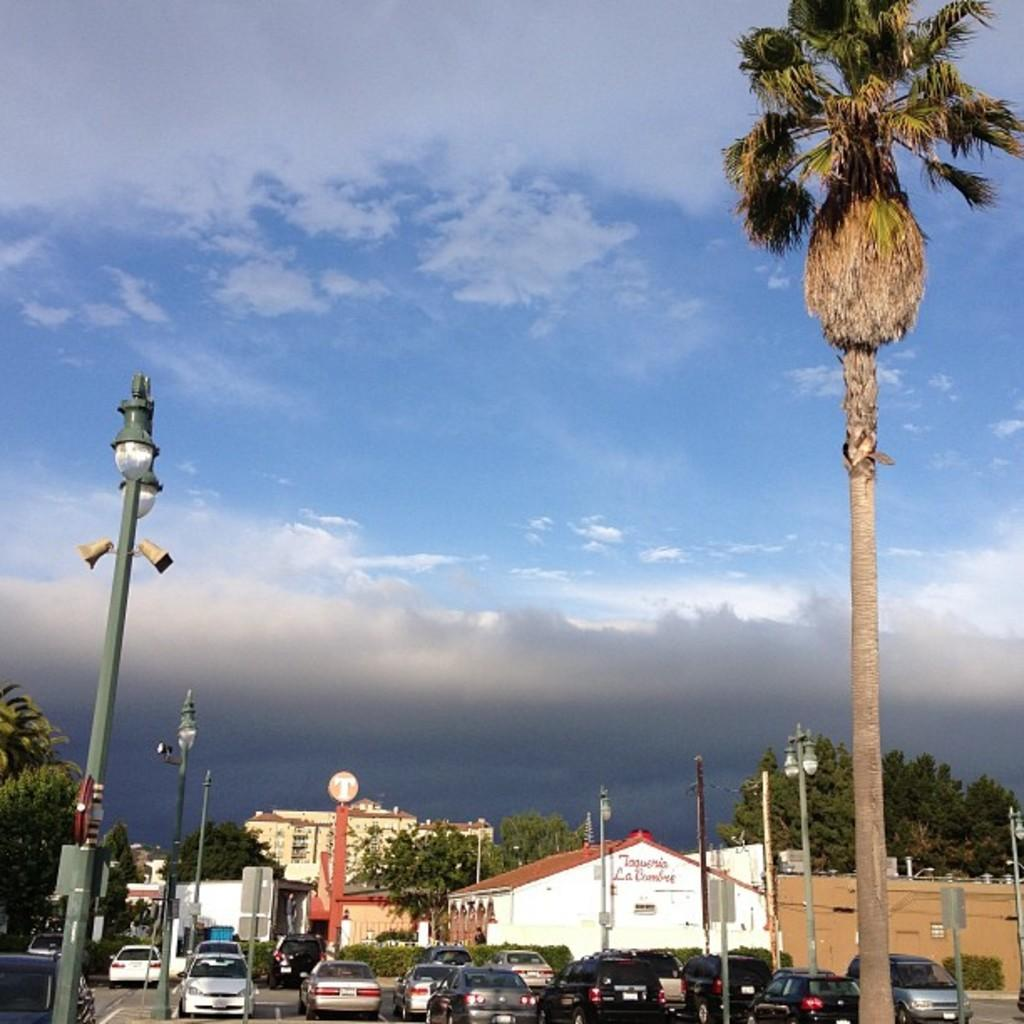What can be seen on the road in the image? There are many vehicles on the road in the image. What else is visible in the image besides the vehicles? There are buildings, trees, and light poles in the image. Can you describe the natural elements in the image? Trees are visible in the image. What part of the natural environment is visible in the image? The sky is visible in the image. How far away is the mother from the vehicles in the image? There is no mother present in the image, so it is not possible to determine her distance from the vehicles. 